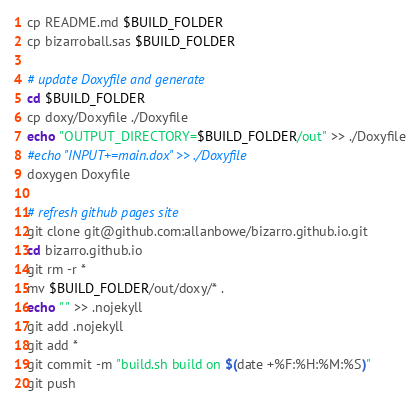Convert code to text. <code><loc_0><loc_0><loc_500><loc_500><_Bash_>cp README.md $BUILD_FOLDER
cp bizarroball.sas $BUILD_FOLDER

# update Doxyfile and generate
cd $BUILD_FOLDER
cp doxy/Doxyfile ./Doxyfile
echo "OUTPUT_DIRECTORY=$BUILD_FOLDER/out" >> ./Doxyfile
#echo "INPUT+=main.dox" >> ./Doxyfile
doxygen Doxyfile

# refresh github pages site
git clone git@github.com:allanbowe/bizarro.github.io.git
cd bizarro.github.io
git rm -r *
mv $BUILD_FOLDER/out/doxy/* .
echo " " >> .nojekyll
git add .nojekyll
git add *
git commit -m "build.sh build on $(date +%F:%H:%M:%S)"
git push

</code> 